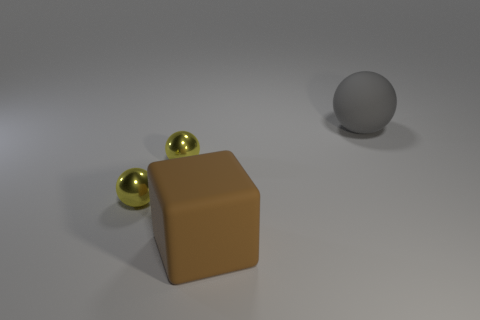How big is the gray object?
Your response must be concise. Large. What is the color of the rubber object right of the brown cube?
Offer a terse response. Gray. How many big brown cubes are there?
Offer a very short reply. 1. Is there a large gray sphere that is to the right of the matte thing that is in front of the rubber thing to the right of the matte block?
Make the answer very short. Yes. There is a gray object that is the same size as the brown object; what is its shape?
Your answer should be very brief. Sphere. What is the shape of the big rubber thing that is on the right side of the big object in front of the gray thing?
Provide a succinct answer. Sphere. Is there anything else that is the same shape as the big brown matte object?
Your answer should be very brief. No. Are there the same number of tiny shiny things on the left side of the brown rubber thing and tiny shiny things?
Offer a very short reply. Yes. How many rubber things are to the left of the big thing that is behind the large cube?
Your answer should be very brief. 1. Are there any other metal things of the same shape as the large gray thing?
Keep it short and to the point. Yes. 